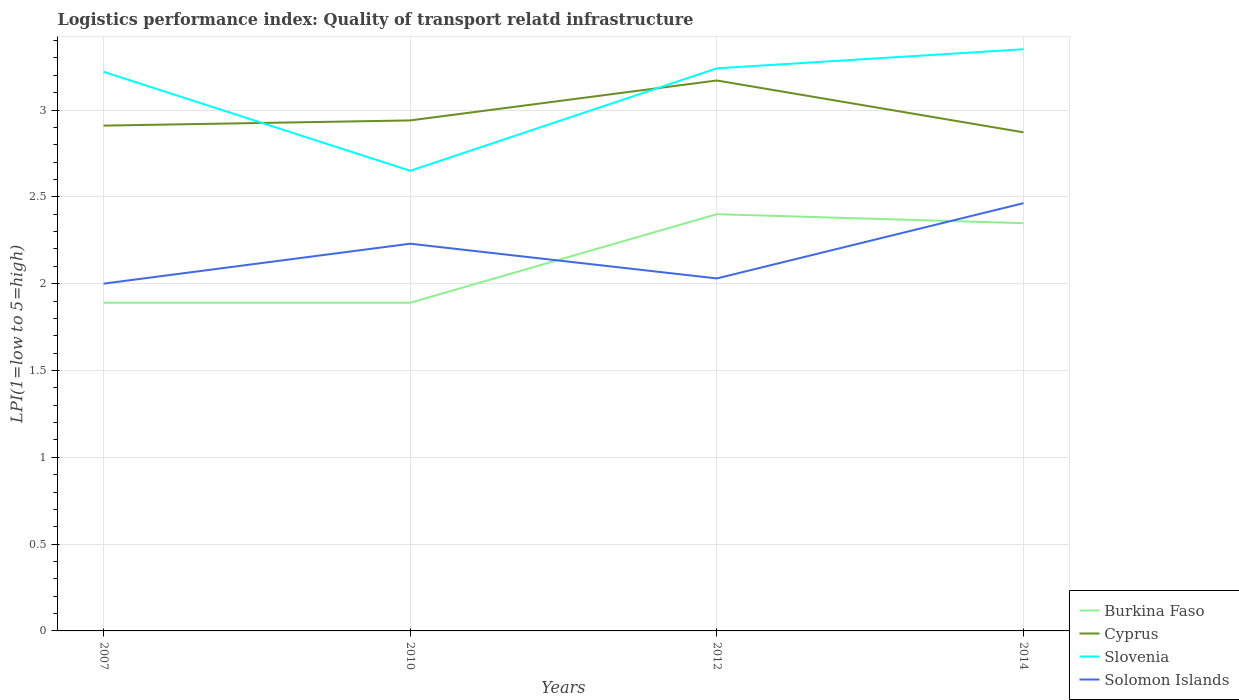Does the line corresponding to Solomon Islands intersect with the line corresponding to Cyprus?
Make the answer very short. No. Is the number of lines equal to the number of legend labels?
Make the answer very short. Yes. Across all years, what is the maximum logistics performance index in Slovenia?
Your response must be concise. 2.65. In which year was the logistics performance index in Burkina Faso maximum?
Provide a short and direct response. 2007. What is the total logistics performance index in Burkina Faso in the graph?
Provide a succinct answer. -0.46. What is the difference between the highest and the second highest logistics performance index in Burkina Faso?
Ensure brevity in your answer.  0.51. What is the difference between the highest and the lowest logistics performance index in Slovenia?
Give a very brief answer. 3. Is the logistics performance index in Slovenia strictly greater than the logistics performance index in Cyprus over the years?
Your answer should be very brief. No. How many lines are there?
Make the answer very short. 4. Are the values on the major ticks of Y-axis written in scientific E-notation?
Your answer should be compact. No. Does the graph contain grids?
Offer a very short reply. Yes. Where does the legend appear in the graph?
Ensure brevity in your answer.  Bottom right. How many legend labels are there?
Give a very brief answer. 4. How are the legend labels stacked?
Offer a very short reply. Vertical. What is the title of the graph?
Provide a succinct answer. Logistics performance index: Quality of transport relatd infrastructure. Does "Eritrea" appear as one of the legend labels in the graph?
Provide a short and direct response. No. What is the label or title of the Y-axis?
Give a very brief answer. LPI(1=low to 5=high). What is the LPI(1=low to 5=high) of Burkina Faso in 2007?
Offer a very short reply. 1.89. What is the LPI(1=low to 5=high) of Cyprus in 2007?
Your response must be concise. 2.91. What is the LPI(1=low to 5=high) in Slovenia in 2007?
Your response must be concise. 3.22. What is the LPI(1=low to 5=high) of Solomon Islands in 2007?
Provide a succinct answer. 2. What is the LPI(1=low to 5=high) in Burkina Faso in 2010?
Provide a short and direct response. 1.89. What is the LPI(1=low to 5=high) of Cyprus in 2010?
Make the answer very short. 2.94. What is the LPI(1=low to 5=high) of Slovenia in 2010?
Provide a succinct answer. 2.65. What is the LPI(1=low to 5=high) of Solomon Islands in 2010?
Provide a short and direct response. 2.23. What is the LPI(1=low to 5=high) of Burkina Faso in 2012?
Offer a very short reply. 2.4. What is the LPI(1=low to 5=high) in Cyprus in 2012?
Offer a terse response. 3.17. What is the LPI(1=low to 5=high) of Slovenia in 2012?
Ensure brevity in your answer.  3.24. What is the LPI(1=low to 5=high) of Solomon Islands in 2012?
Your response must be concise. 2.03. What is the LPI(1=low to 5=high) in Burkina Faso in 2014?
Ensure brevity in your answer.  2.35. What is the LPI(1=low to 5=high) of Cyprus in 2014?
Keep it short and to the point. 2.87. What is the LPI(1=low to 5=high) of Slovenia in 2014?
Give a very brief answer. 3.35. What is the LPI(1=low to 5=high) of Solomon Islands in 2014?
Offer a terse response. 2.46. Across all years, what is the maximum LPI(1=low to 5=high) in Cyprus?
Your answer should be compact. 3.17. Across all years, what is the maximum LPI(1=low to 5=high) in Slovenia?
Provide a short and direct response. 3.35. Across all years, what is the maximum LPI(1=low to 5=high) of Solomon Islands?
Provide a short and direct response. 2.46. Across all years, what is the minimum LPI(1=low to 5=high) in Burkina Faso?
Give a very brief answer. 1.89. Across all years, what is the minimum LPI(1=low to 5=high) in Cyprus?
Provide a short and direct response. 2.87. Across all years, what is the minimum LPI(1=low to 5=high) of Slovenia?
Offer a very short reply. 2.65. Across all years, what is the minimum LPI(1=low to 5=high) in Solomon Islands?
Make the answer very short. 2. What is the total LPI(1=low to 5=high) of Burkina Faso in the graph?
Your answer should be very brief. 8.53. What is the total LPI(1=low to 5=high) in Cyprus in the graph?
Offer a very short reply. 11.89. What is the total LPI(1=low to 5=high) of Slovenia in the graph?
Offer a terse response. 12.46. What is the total LPI(1=low to 5=high) of Solomon Islands in the graph?
Provide a succinct answer. 8.72. What is the difference between the LPI(1=low to 5=high) of Cyprus in 2007 and that in 2010?
Offer a very short reply. -0.03. What is the difference between the LPI(1=low to 5=high) in Slovenia in 2007 and that in 2010?
Your response must be concise. 0.57. What is the difference between the LPI(1=low to 5=high) in Solomon Islands in 2007 and that in 2010?
Make the answer very short. -0.23. What is the difference between the LPI(1=low to 5=high) of Burkina Faso in 2007 and that in 2012?
Offer a very short reply. -0.51. What is the difference between the LPI(1=low to 5=high) of Cyprus in 2007 and that in 2012?
Provide a succinct answer. -0.26. What is the difference between the LPI(1=low to 5=high) in Slovenia in 2007 and that in 2012?
Provide a succinct answer. -0.02. What is the difference between the LPI(1=low to 5=high) in Solomon Islands in 2007 and that in 2012?
Your answer should be very brief. -0.03. What is the difference between the LPI(1=low to 5=high) of Burkina Faso in 2007 and that in 2014?
Give a very brief answer. -0.46. What is the difference between the LPI(1=low to 5=high) in Cyprus in 2007 and that in 2014?
Provide a short and direct response. 0.04. What is the difference between the LPI(1=low to 5=high) in Slovenia in 2007 and that in 2014?
Your response must be concise. -0.13. What is the difference between the LPI(1=low to 5=high) of Solomon Islands in 2007 and that in 2014?
Provide a short and direct response. -0.46. What is the difference between the LPI(1=low to 5=high) of Burkina Faso in 2010 and that in 2012?
Your response must be concise. -0.51. What is the difference between the LPI(1=low to 5=high) of Cyprus in 2010 and that in 2012?
Your answer should be very brief. -0.23. What is the difference between the LPI(1=low to 5=high) of Slovenia in 2010 and that in 2012?
Provide a short and direct response. -0.59. What is the difference between the LPI(1=low to 5=high) of Burkina Faso in 2010 and that in 2014?
Your response must be concise. -0.46. What is the difference between the LPI(1=low to 5=high) in Cyprus in 2010 and that in 2014?
Ensure brevity in your answer.  0.07. What is the difference between the LPI(1=low to 5=high) of Slovenia in 2010 and that in 2014?
Provide a short and direct response. -0.7. What is the difference between the LPI(1=low to 5=high) in Solomon Islands in 2010 and that in 2014?
Provide a short and direct response. -0.23. What is the difference between the LPI(1=low to 5=high) in Burkina Faso in 2012 and that in 2014?
Keep it short and to the point. 0.05. What is the difference between the LPI(1=low to 5=high) in Cyprus in 2012 and that in 2014?
Make the answer very short. 0.3. What is the difference between the LPI(1=low to 5=high) in Slovenia in 2012 and that in 2014?
Your response must be concise. -0.11. What is the difference between the LPI(1=low to 5=high) in Solomon Islands in 2012 and that in 2014?
Your response must be concise. -0.43. What is the difference between the LPI(1=low to 5=high) in Burkina Faso in 2007 and the LPI(1=low to 5=high) in Cyprus in 2010?
Ensure brevity in your answer.  -1.05. What is the difference between the LPI(1=low to 5=high) in Burkina Faso in 2007 and the LPI(1=low to 5=high) in Slovenia in 2010?
Ensure brevity in your answer.  -0.76. What is the difference between the LPI(1=low to 5=high) in Burkina Faso in 2007 and the LPI(1=low to 5=high) in Solomon Islands in 2010?
Your answer should be very brief. -0.34. What is the difference between the LPI(1=low to 5=high) in Cyprus in 2007 and the LPI(1=low to 5=high) in Slovenia in 2010?
Provide a short and direct response. 0.26. What is the difference between the LPI(1=low to 5=high) in Cyprus in 2007 and the LPI(1=low to 5=high) in Solomon Islands in 2010?
Make the answer very short. 0.68. What is the difference between the LPI(1=low to 5=high) in Slovenia in 2007 and the LPI(1=low to 5=high) in Solomon Islands in 2010?
Keep it short and to the point. 0.99. What is the difference between the LPI(1=low to 5=high) in Burkina Faso in 2007 and the LPI(1=low to 5=high) in Cyprus in 2012?
Provide a short and direct response. -1.28. What is the difference between the LPI(1=low to 5=high) in Burkina Faso in 2007 and the LPI(1=low to 5=high) in Slovenia in 2012?
Give a very brief answer. -1.35. What is the difference between the LPI(1=low to 5=high) of Burkina Faso in 2007 and the LPI(1=low to 5=high) of Solomon Islands in 2012?
Offer a terse response. -0.14. What is the difference between the LPI(1=low to 5=high) in Cyprus in 2007 and the LPI(1=low to 5=high) in Slovenia in 2012?
Your answer should be very brief. -0.33. What is the difference between the LPI(1=low to 5=high) of Cyprus in 2007 and the LPI(1=low to 5=high) of Solomon Islands in 2012?
Offer a terse response. 0.88. What is the difference between the LPI(1=low to 5=high) in Slovenia in 2007 and the LPI(1=low to 5=high) in Solomon Islands in 2012?
Your answer should be very brief. 1.19. What is the difference between the LPI(1=low to 5=high) in Burkina Faso in 2007 and the LPI(1=low to 5=high) in Cyprus in 2014?
Offer a terse response. -0.98. What is the difference between the LPI(1=low to 5=high) of Burkina Faso in 2007 and the LPI(1=low to 5=high) of Slovenia in 2014?
Keep it short and to the point. -1.46. What is the difference between the LPI(1=low to 5=high) in Burkina Faso in 2007 and the LPI(1=low to 5=high) in Solomon Islands in 2014?
Your response must be concise. -0.57. What is the difference between the LPI(1=low to 5=high) of Cyprus in 2007 and the LPI(1=low to 5=high) of Slovenia in 2014?
Keep it short and to the point. -0.44. What is the difference between the LPI(1=low to 5=high) of Cyprus in 2007 and the LPI(1=low to 5=high) of Solomon Islands in 2014?
Keep it short and to the point. 0.45. What is the difference between the LPI(1=low to 5=high) in Slovenia in 2007 and the LPI(1=low to 5=high) in Solomon Islands in 2014?
Your answer should be very brief. 0.76. What is the difference between the LPI(1=low to 5=high) of Burkina Faso in 2010 and the LPI(1=low to 5=high) of Cyprus in 2012?
Your answer should be very brief. -1.28. What is the difference between the LPI(1=low to 5=high) in Burkina Faso in 2010 and the LPI(1=low to 5=high) in Slovenia in 2012?
Your answer should be very brief. -1.35. What is the difference between the LPI(1=low to 5=high) of Burkina Faso in 2010 and the LPI(1=low to 5=high) of Solomon Islands in 2012?
Keep it short and to the point. -0.14. What is the difference between the LPI(1=low to 5=high) in Cyprus in 2010 and the LPI(1=low to 5=high) in Slovenia in 2012?
Your response must be concise. -0.3. What is the difference between the LPI(1=low to 5=high) in Cyprus in 2010 and the LPI(1=low to 5=high) in Solomon Islands in 2012?
Give a very brief answer. 0.91. What is the difference between the LPI(1=low to 5=high) of Slovenia in 2010 and the LPI(1=low to 5=high) of Solomon Islands in 2012?
Provide a succinct answer. 0.62. What is the difference between the LPI(1=low to 5=high) in Burkina Faso in 2010 and the LPI(1=low to 5=high) in Cyprus in 2014?
Offer a very short reply. -0.98. What is the difference between the LPI(1=low to 5=high) of Burkina Faso in 2010 and the LPI(1=low to 5=high) of Slovenia in 2014?
Your answer should be compact. -1.46. What is the difference between the LPI(1=low to 5=high) of Burkina Faso in 2010 and the LPI(1=low to 5=high) of Solomon Islands in 2014?
Ensure brevity in your answer.  -0.57. What is the difference between the LPI(1=low to 5=high) of Cyprus in 2010 and the LPI(1=low to 5=high) of Slovenia in 2014?
Your answer should be compact. -0.41. What is the difference between the LPI(1=low to 5=high) in Cyprus in 2010 and the LPI(1=low to 5=high) in Solomon Islands in 2014?
Provide a short and direct response. 0.48. What is the difference between the LPI(1=low to 5=high) of Slovenia in 2010 and the LPI(1=low to 5=high) of Solomon Islands in 2014?
Ensure brevity in your answer.  0.19. What is the difference between the LPI(1=low to 5=high) of Burkina Faso in 2012 and the LPI(1=low to 5=high) of Cyprus in 2014?
Your answer should be compact. -0.47. What is the difference between the LPI(1=low to 5=high) in Burkina Faso in 2012 and the LPI(1=low to 5=high) in Slovenia in 2014?
Give a very brief answer. -0.95. What is the difference between the LPI(1=low to 5=high) of Burkina Faso in 2012 and the LPI(1=low to 5=high) of Solomon Islands in 2014?
Your answer should be very brief. -0.06. What is the difference between the LPI(1=low to 5=high) in Cyprus in 2012 and the LPI(1=low to 5=high) in Slovenia in 2014?
Your answer should be compact. -0.18. What is the difference between the LPI(1=low to 5=high) of Cyprus in 2012 and the LPI(1=low to 5=high) of Solomon Islands in 2014?
Make the answer very short. 0.71. What is the difference between the LPI(1=low to 5=high) in Slovenia in 2012 and the LPI(1=low to 5=high) in Solomon Islands in 2014?
Ensure brevity in your answer.  0.78. What is the average LPI(1=low to 5=high) of Burkina Faso per year?
Give a very brief answer. 2.13. What is the average LPI(1=low to 5=high) of Cyprus per year?
Offer a very short reply. 2.97. What is the average LPI(1=low to 5=high) of Slovenia per year?
Provide a succinct answer. 3.12. What is the average LPI(1=low to 5=high) of Solomon Islands per year?
Offer a very short reply. 2.18. In the year 2007, what is the difference between the LPI(1=low to 5=high) of Burkina Faso and LPI(1=low to 5=high) of Cyprus?
Make the answer very short. -1.02. In the year 2007, what is the difference between the LPI(1=low to 5=high) of Burkina Faso and LPI(1=low to 5=high) of Slovenia?
Your answer should be compact. -1.33. In the year 2007, what is the difference between the LPI(1=low to 5=high) in Burkina Faso and LPI(1=low to 5=high) in Solomon Islands?
Keep it short and to the point. -0.11. In the year 2007, what is the difference between the LPI(1=low to 5=high) in Cyprus and LPI(1=low to 5=high) in Slovenia?
Your response must be concise. -0.31. In the year 2007, what is the difference between the LPI(1=low to 5=high) in Cyprus and LPI(1=low to 5=high) in Solomon Islands?
Provide a short and direct response. 0.91. In the year 2007, what is the difference between the LPI(1=low to 5=high) of Slovenia and LPI(1=low to 5=high) of Solomon Islands?
Offer a very short reply. 1.22. In the year 2010, what is the difference between the LPI(1=low to 5=high) in Burkina Faso and LPI(1=low to 5=high) in Cyprus?
Keep it short and to the point. -1.05. In the year 2010, what is the difference between the LPI(1=low to 5=high) in Burkina Faso and LPI(1=low to 5=high) in Slovenia?
Provide a succinct answer. -0.76. In the year 2010, what is the difference between the LPI(1=low to 5=high) of Burkina Faso and LPI(1=low to 5=high) of Solomon Islands?
Provide a succinct answer. -0.34. In the year 2010, what is the difference between the LPI(1=low to 5=high) of Cyprus and LPI(1=low to 5=high) of Slovenia?
Your answer should be compact. 0.29. In the year 2010, what is the difference between the LPI(1=low to 5=high) in Cyprus and LPI(1=low to 5=high) in Solomon Islands?
Offer a very short reply. 0.71. In the year 2010, what is the difference between the LPI(1=low to 5=high) of Slovenia and LPI(1=low to 5=high) of Solomon Islands?
Ensure brevity in your answer.  0.42. In the year 2012, what is the difference between the LPI(1=low to 5=high) of Burkina Faso and LPI(1=low to 5=high) of Cyprus?
Keep it short and to the point. -0.77. In the year 2012, what is the difference between the LPI(1=low to 5=high) of Burkina Faso and LPI(1=low to 5=high) of Slovenia?
Offer a terse response. -0.84. In the year 2012, what is the difference between the LPI(1=low to 5=high) in Burkina Faso and LPI(1=low to 5=high) in Solomon Islands?
Your response must be concise. 0.37. In the year 2012, what is the difference between the LPI(1=low to 5=high) in Cyprus and LPI(1=low to 5=high) in Slovenia?
Ensure brevity in your answer.  -0.07. In the year 2012, what is the difference between the LPI(1=low to 5=high) in Cyprus and LPI(1=low to 5=high) in Solomon Islands?
Ensure brevity in your answer.  1.14. In the year 2012, what is the difference between the LPI(1=low to 5=high) of Slovenia and LPI(1=low to 5=high) of Solomon Islands?
Provide a succinct answer. 1.21. In the year 2014, what is the difference between the LPI(1=low to 5=high) of Burkina Faso and LPI(1=low to 5=high) of Cyprus?
Provide a short and direct response. -0.52. In the year 2014, what is the difference between the LPI(1=low to 5=high) in Burkina Faso and LPI(1=low to 5=high) in Slovenia?
Your answer should be compact. -1. In the year 2014, what is the difference between the LPI(1=low to 5=high) in Burkina Faso and LPI(1=low to 5=high) in Solomon Islands?
Provide a succinct answer. -0.12. In the year 2014, what is the difference between the LPI(1=low to 5=high) of Cyprus and LPI(1=low to 5=high) of Slovenia?
Keep it short and to the point. -0.48. In the year 2014, what is the difference between the LPI(1=low to 5=high) of Cyprus and LPI(1=low to 5=high) of Solomon Islands?
Provide a short and direct response. 0.41. In the year 2014, what is the difference between the LPI(1=low to 5=high) of Slovenia and LPI(1=low to 5=high) of Solomon Islands?
Your answer should be compact. 0.89. What is the ratio of the LPI(1=low to 5=high) in Burkina Faso in 2007 to that in 2010?
Offer a terse response. 1. What is the ratio of the LPI(1=low to 5=high) in Cyprus in 2007 to that in 2010?
Offer a terse response. 0.99. What is the ratio of the LPI(1=low to 5=high) of Slovenia in 2007 to that in 2010?
Provide a short and direct response. 1.22. What is the ratio of the LPI(1=low to 5=high) in Solomon Islands in 2007 to that in 2010?
Keep it short and to the point. 0.9. What is the ratio of the LPI(1=low to 5=high) of Burkina Faso in 2007 to that in 2012?
Provide a short and direct response. 0.79. What is the ratio of the LPI(1=low to 5=high) of Cyprus in 2007 to that in 2012?
Ensure brevity in your answer.  0.92. What is the ratio of the LPI(1=low to 5=high) of Slovenia in 2007 to that in 2012?
Make the answer very short. 0.99. What is the ratio of the LPI(1=low to 5=high) of Solomon Islands in 2007 to that in 2012?
Provide a succinct answer. 0.99. What is the ratio of the LPI(1=low to 5=high) of Burkina Faso in 2007 to that in 2014?
Offer a terse response. 0.8. What is the ratio of the LPI(1=low to 5=high) of Cyprus in 2007 to that in 2014?
Provide a succinct answer. 1.01. What is the ratio of the LPI(1=low to 5=high) of Slovenia in 2007 to that in 2014?
Your answer should be compact. 0.96. What is the ratio of the LPI(1=low to 5=high) of Solomon Islands in 2007 to that in 2014?
Give a very brief answer. 0.81. What is the ratio of the LPI(1=low to 5=high) of Burkina Faso in 2010 to that in 2012?
Your answer should be very brief. 0.79. What is the ratio of the LPI(1=low to 5=high) in Cyprus in 2010 to that in 2012?
Make the answer very short. 0.93. What is the ratio of the LPI(1=low to 5=high) of Slovenia in 2010 to that in 2012?
Offer a very short reply. 0.82. What is the ratio of the LPI(1=low to 5=high) of Solomon Islands in 2010 to that in 2012?
Offer a terse response. 1.1. What is the ratio of the LPI(1=low to 5=high) in Burkina Faso in 2010 to that in 2014?
Keep it short and to the point. 0.8. What is the ratio of the LPI(1=low to 5=high) in Cyprus in 2010 to that in 2014?
Your answer should be very brief. 1.02. What is the ratio of the LPI(1=low to 5=high) of Slovenia in 2010 to that in 2014?
Give a very brief answer. 0.79. What is the ratio of the LPI(1=low to 5=high) of Solomon Islands in 2010 to that in 2014?
Ensure brevity in your answer.  0.91. What is the ratio of the LPI(1=low to 5=high) of Burkina Faso in 2012 to that in 2014?
Give a very brief answer. 1.02. What is the ratio of the LPI(1=low to 5=high) of Cyprus in 2012 to that in 2014?
Your response must be concise. 1.1. What is the ratio of the LPI(1=low to 5=high) of Slovenia in 2012 to that in 2014?
Provide a succinct answer. 0.97. What is the ratio of the LPI(1=low to 5=high) of Solomon Islands in 2012 to that in 2014?
Provide a short and direct response. 0.82. What is the difference between the highest and the second highest LPI(1=low to 5=high) in Burkina Faso?
Your answer should be compact. 0.05. What is the difference between the highest and the second highest LPI(1=low to 5=high) of Cyprus?
Your answer should be compact. 0.23. What is the difference between the highest and the second highest LPI(1=low to 5=high) in Slovenia?
Your answer should be very brief. 0.11. What is the difference between the highest and the second highest LPI(1=low to 5=high) in Solomon Islands?
Your response must be concise. 0.23. What is the difference between the highest and the lowest LPI(1=low to 5=high) of Burkina Faso?
Provide a succinct answer. 0.51. What is the difference between the highest and the lowest LPI(1=low to 5=high) in Cyprus?
Provide a short and direct response. 0.3. What is the difference between the highest and the lowest LPI(1=low to 5=high) of Slovenia?
Your answer should be very brief. 0.7. What is the difference between the highest and the lowest LPI(1=low to 5=high) of Solomon Islands?
Your answer should be very brief. 0.46. 